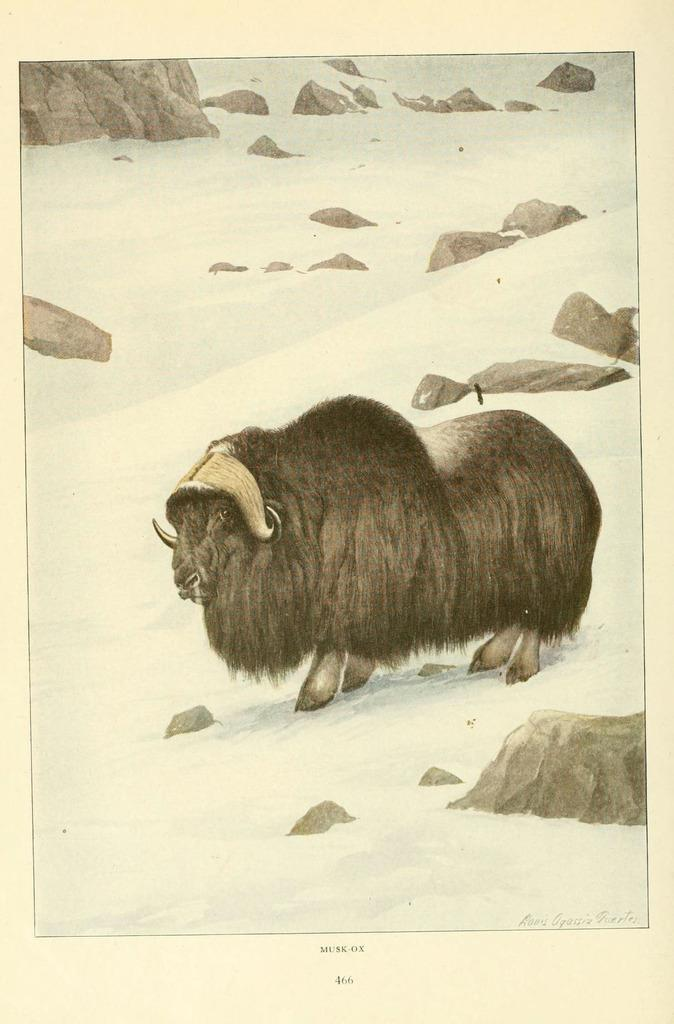What type of artwork is depicted in the image? The image is a painting. What can be seen on the land in the painting? There is an animal standing on the land, and there are rocks on the land. How is the land depicted in the painting? The land is covered with snow. Is there any text included in the painting? Yes, there is text at the bottom of the image. How many times has the pot been folded in the image? There is no pot present in the image, so it cannot be folded. 